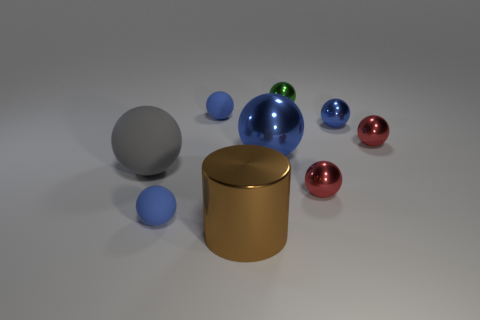Does the tiny blue ball in front of the large blue object have the same material as the small blue object on the right side of the cylinder?
Ensure brevity in your answer.  No. Are there more things that are on the left side of the small blue shiny object than small blue metal balls that are on the left side of the large cylinder?
Give a very brief answer. Yes. Is there anything else that is the same shape as the green thing?
Ensure brevity in your answer.  Yes. The tiny ball that is in front of the large rubber thing and to the right of the big blue ball is made of what material?
Give a very brief answer. Metal. Do the large gray sphere and the large ball to the right of the big brown metallic object have the same material?
Give a very brief answer. No. Is there anything else that is the same size as the gray rubber ball?
Make the answer very short. Yes. How many objects are rubber balls or metal objects that are to the right of the small green metal sphere?
Keep it short and to the point. 6. Does the brown shiny cylinder in front of the tiny green shiny object have the same size as the blue metallic object right of the big shiny sphere?
Provide a short and direct response. No. How many other things are the same color as the large metallic ball?
Provide a succinct answer. 3. There is a brown metal cylinder; is its size the same as the blue matte ball that is behind the gray matte thing?
Ensure brevity in your answer.  No. 